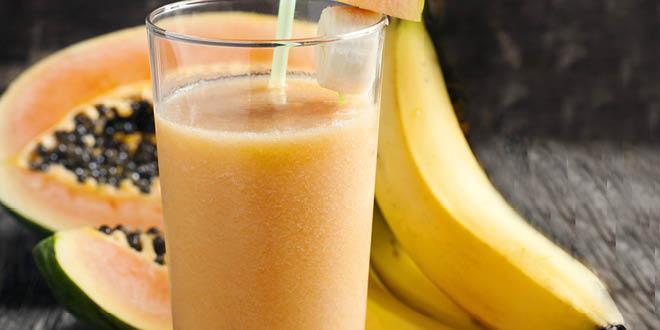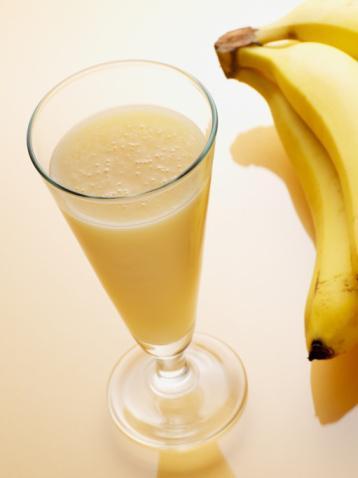The first image is the image on the left, the second image is the image on the right. Evaluate the accuracy of this statement regarding the images: "The straws have stripes on them.". Is it true? Answer yes or no. No. The first image is the image on the left, the second image is the image on the right. Given the left and right images, does the statement "The image on the left shows two smoothie glasses next to at least one banana." hold true? Answer yes or no. No. 